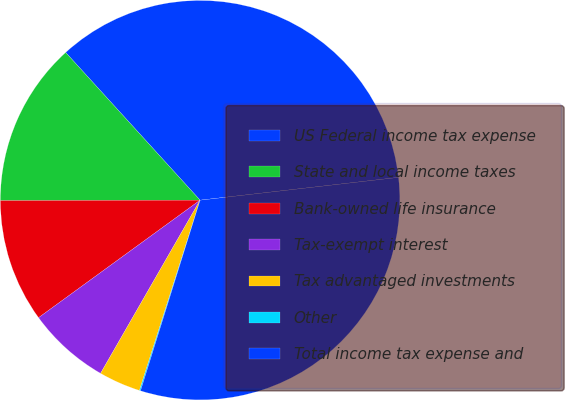Convert chart to OTSL. <chart><loc_0><loc_0><loc_500><loc_500><pie_chart><fcel>US Federal income tax expense<fcel>State and local income taxes<fcel>Bank-owned life insurance<fcel>Tax-exempt interest<fcel>Tax advantaged investments<fcel>Other<fcel>Total income tax expense and<nl><fcel>34.93%<fcel>13.28%<fcel>9.98%<fcel>6.69%<fcel>3.39%<fcel>0.09%<fcel>31.64%<nl></chart> 